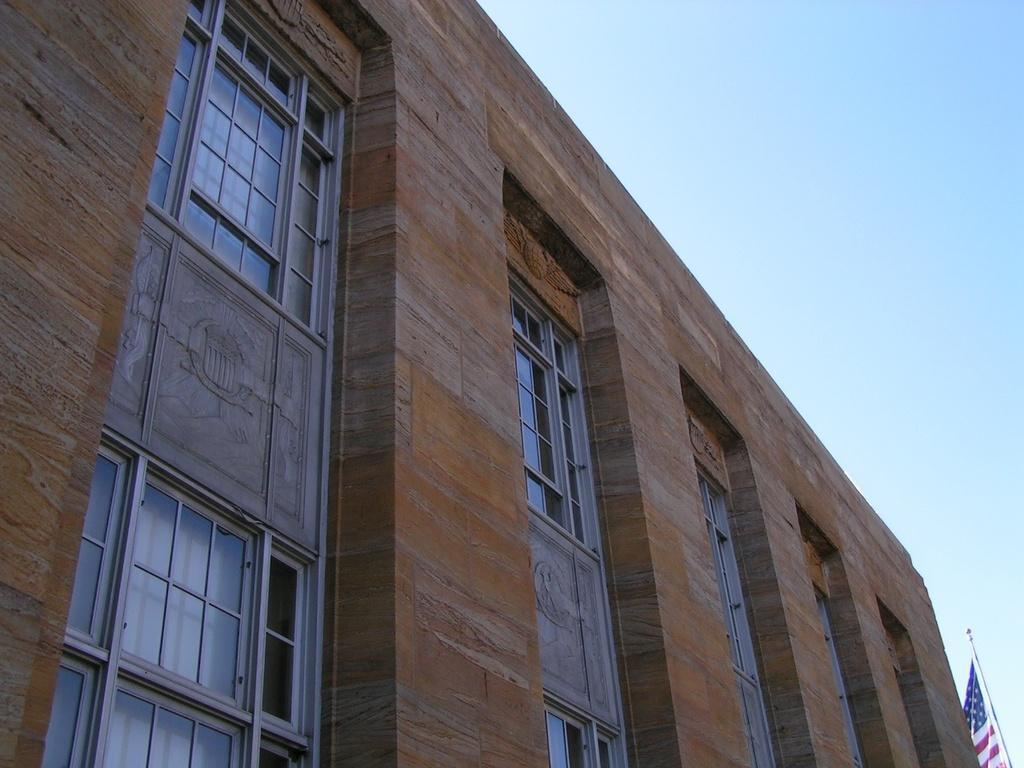In one or two sentences, can you explain what this image depicts? In this image we can see building, flag to the flag post and sky. 